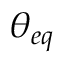Convert formula to latex. <formula><loc_0><loc_0><loc_500><loc_500>{ \theta _ { e q } }</formula> 